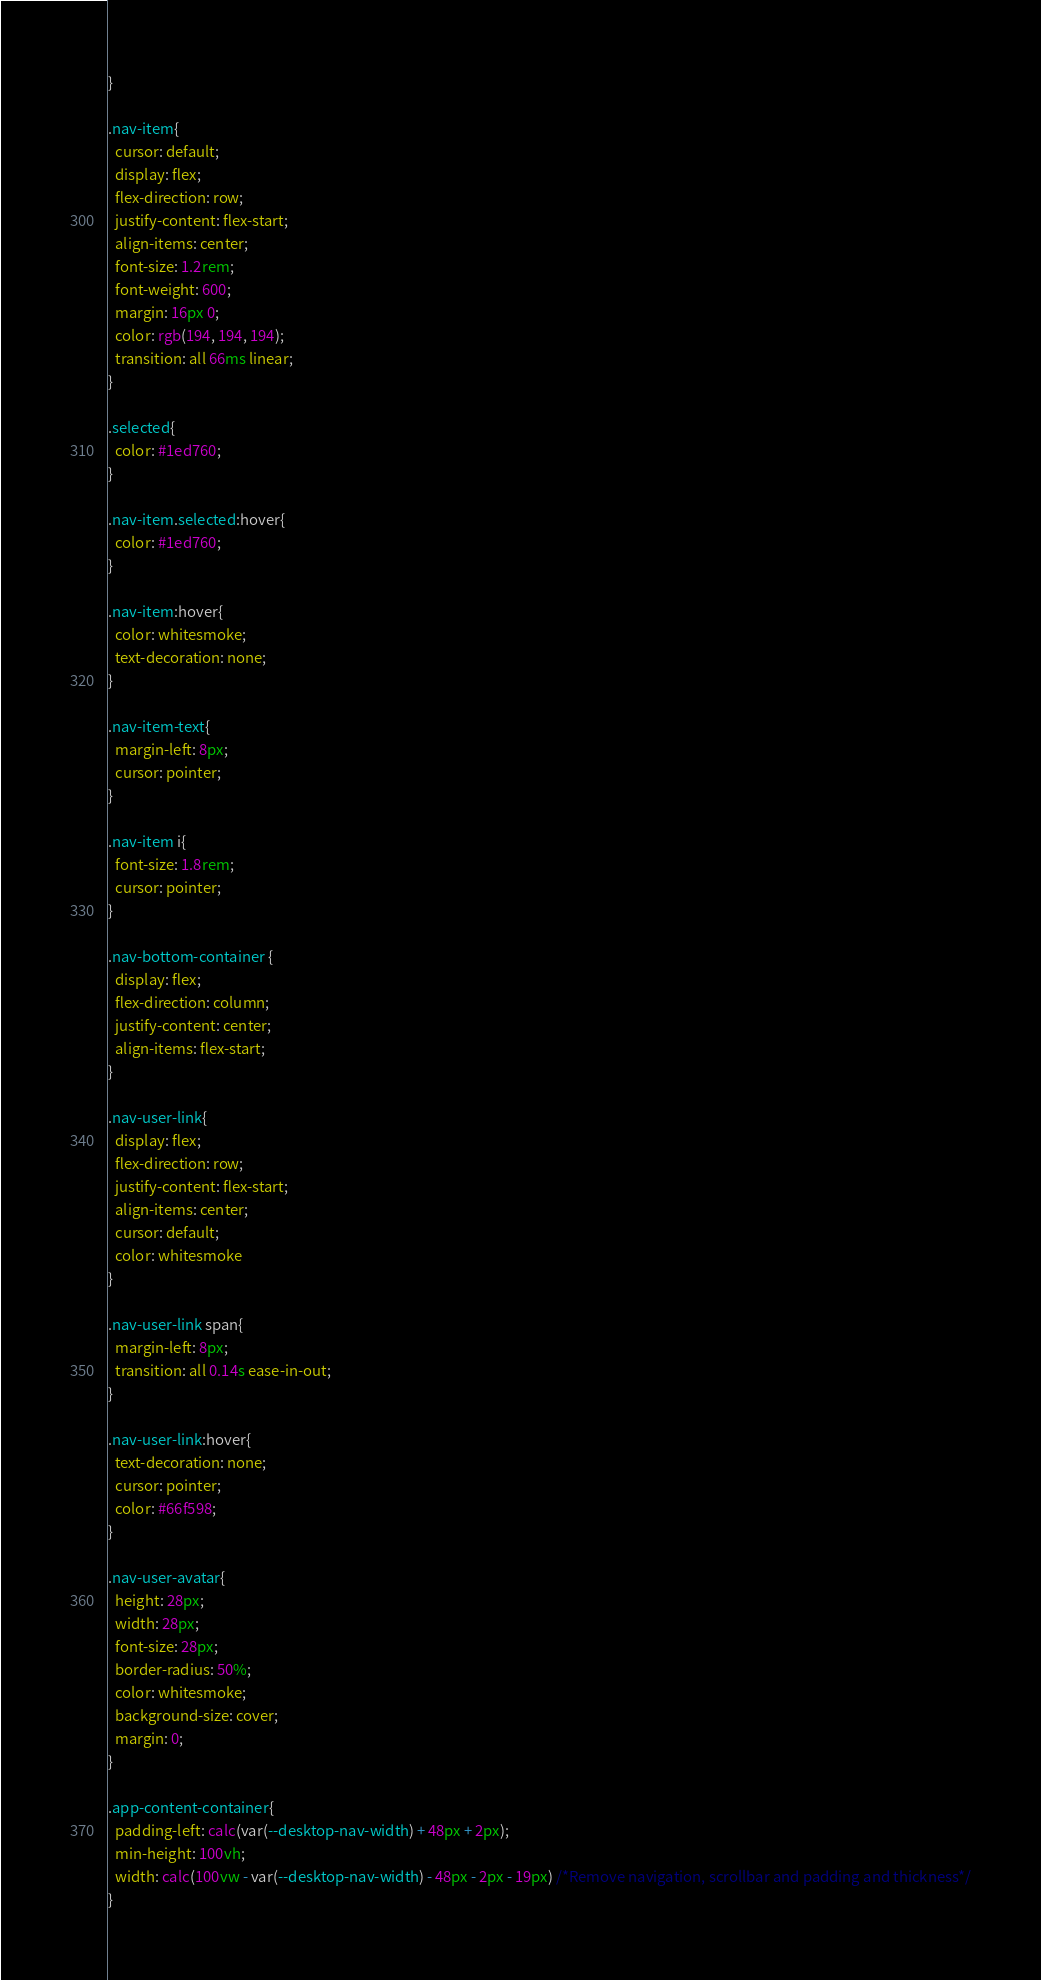Convert code to text. <code><loc_0><loc_0><loc_500><loc_500><_CSS_>}

.nav-item{
  cursor: default;
  display: flex;
  flex-direction: row;
  justify-content: flex-start;
  align-items: center;
  font-size: 1.2rem;
  font-weight: 600;
  margin: 16px 0;
  color: rgb(194, 194, 194);
  transition: all 66ms linear;
}

.selected{
  color: #1ed760;
}

.nav-item.selected:hover{
  color: #1ed760;
}

.nav-item:hover{
  color: whitesmoke;
  text-decoration: none;
}

.nav-item-text{
  margin-left: 8px;
  cursor: pointer;
}

.nav-item i{
  font-size: 1.8rem;
  cursor: pointer;
}

.nav-bottom-container {
  display: flex;
  flex-direction: column;
  justify-content: center;
  align-items: flex-start;
}

.nav-user-link{
  display: flex;
  flex-direction: row;
  justify-content: flex-start;
  align-items: center;
  cursor: default;
  color: whitesmoke
}

.nav-user-link span{
  margin-left: 8px;
  transition: all 0.14s ease-in-out;
}

.nav-user-link:hover{
  text-decoration: none;
  cursor: pointer;
  color: #66f598;
}

.nav-user-avatar{
  height: 28px;
  width: 28px;
  font-size: 28px;
  border-radius: 50%;
  color: whitesmoke;
  background-size: cover;
  margin: 0;
}

.app-content-container{
  padding-left: calc(var(--desktop-nav-width) + 48px + 2px);
  min-height: 100vh;
  width: calc(100vw - var(--desktop-nav-width) - 48px - 2px - 19px) /*Remove navigation, scrollbar and padding and thickness*/
}
</code> 